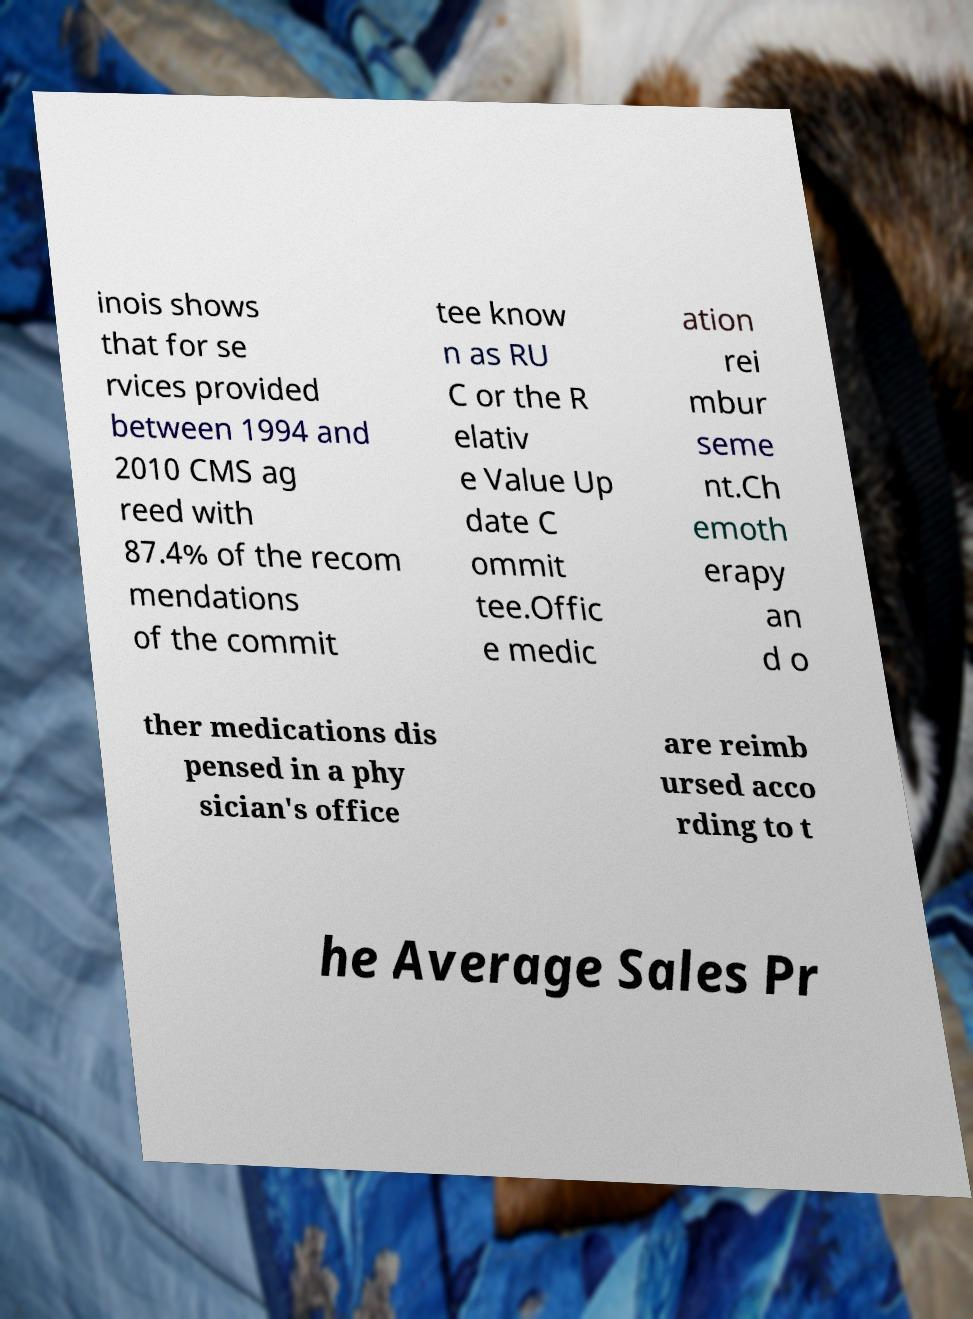Can you accurately transcribe the text from the provided image for me? inois shows that for se rvices provided between 1994 and 2010 CMS ag reed with 87.4% of the recom mendations of the commit tee know n as RU C or the R elativ e Value Up date C ommit tee.Offic e medic ation rei mbur seme nt.Ch emoth erapy an d o ther medications dis pensed in a phy sician's office are reimb ursed acco rding to t he Average Sales Pr 